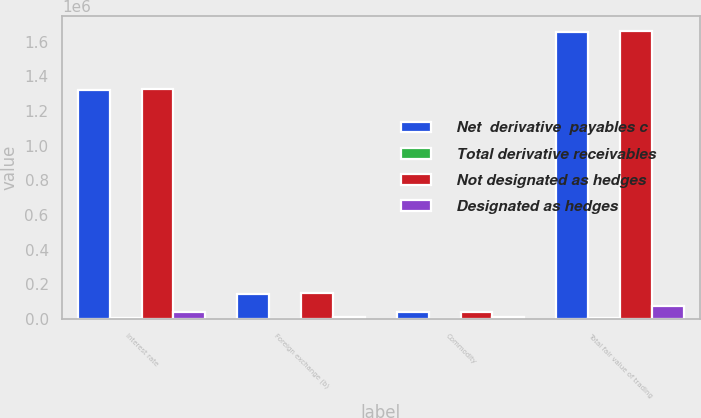Convert chart to OTSL. <chart><loc_0><loc_0><loc_500><loc_500><stacked_bar_chart><ecel><fcel>Interest rate<fcel>Foreign exchange (b)<fcel>Commodity<fcel>Total fair value of trading<nl><fcel>Net  derivative  payables c<fcel>1.32318e+06<fcel>146682<fcel>43039<fcel>1.65415e+06<nl><fcel>Total derivative receivables<fcel>6064<fcel>1577<fcel>586<fcel>8227<nl><fcel>Not designated as hedges<fcel>1.32925e+06<fcel>148259<fcel>43625<fcel>1.66238e+06<nl><fcel>Designated as hedges<fcel>39205<fcel>14142<fcel>10635<fcel>74983<nl></chart> 